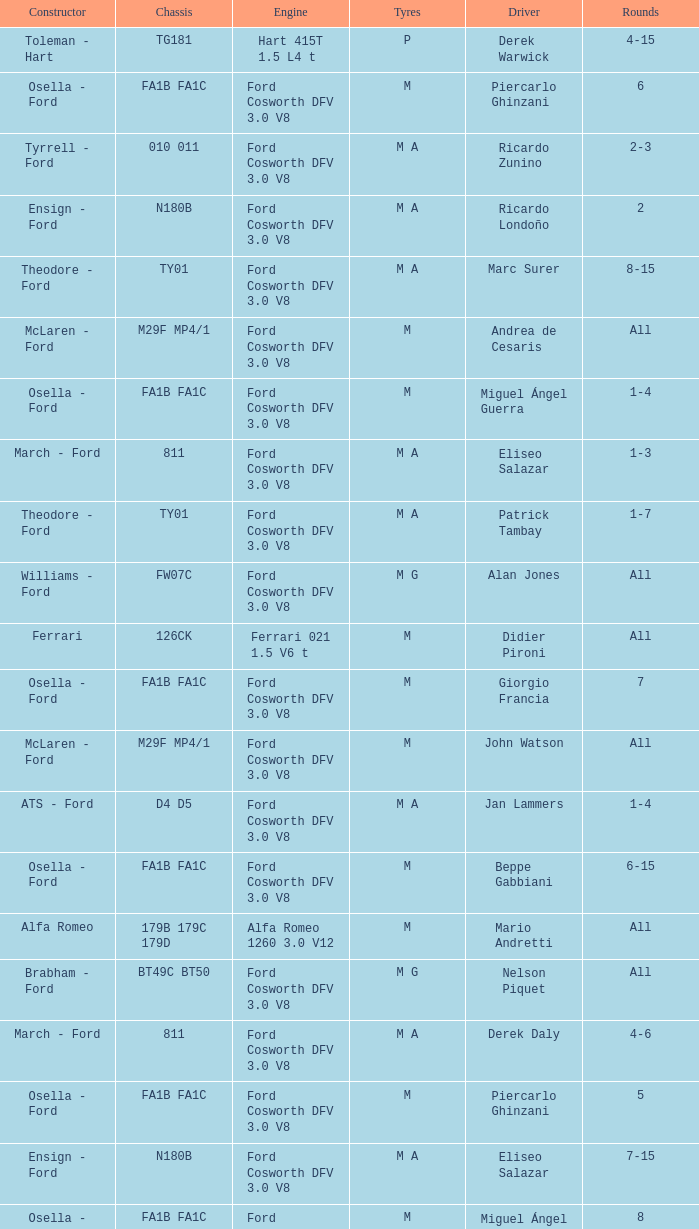Who constructed the car that Derek Warwick raced in with a TG181 chassis? Toleman - Hart. 